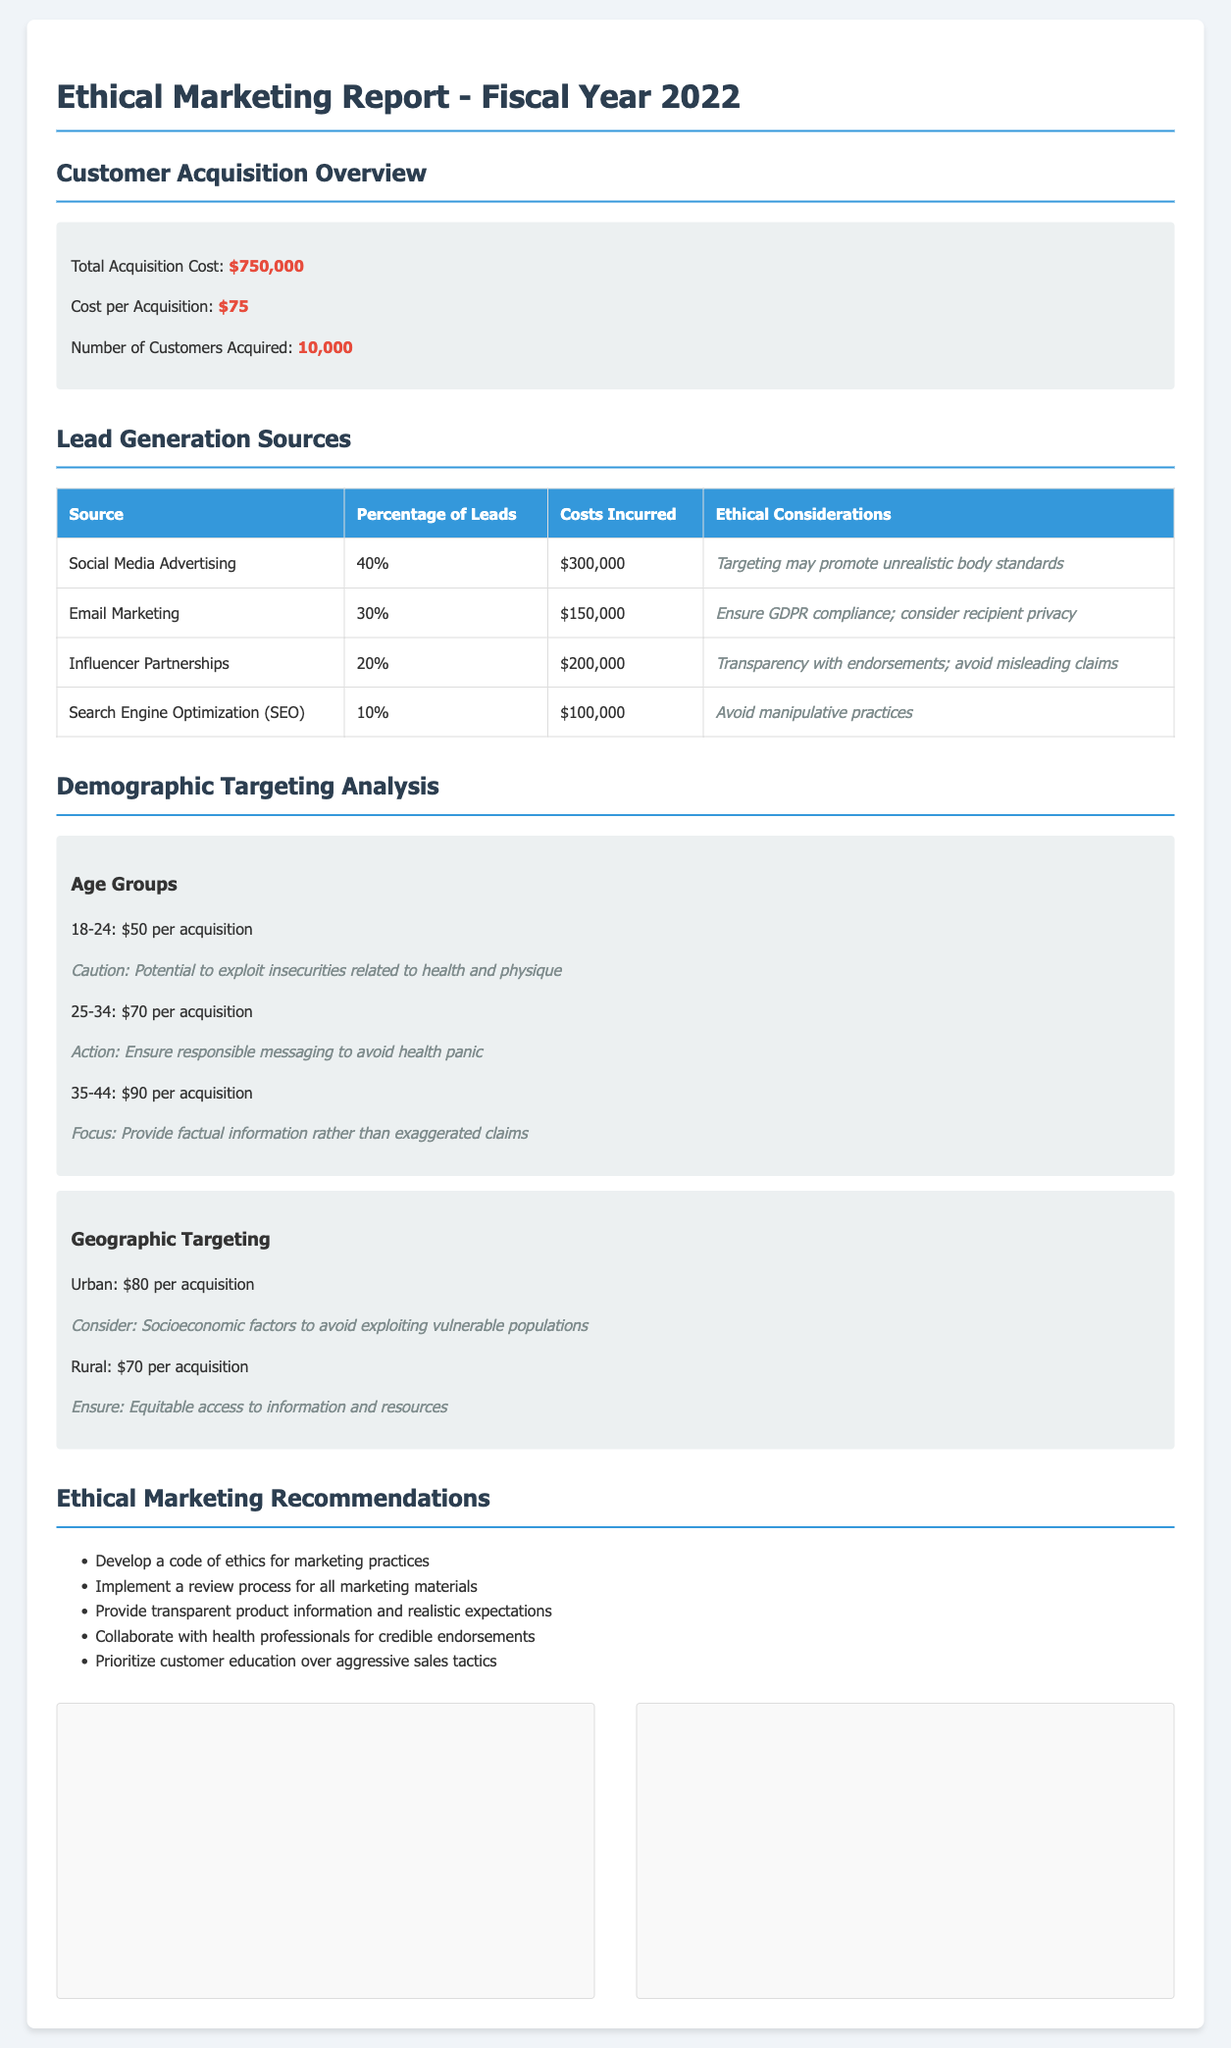what is the total acquisition cost? The total customer acquisition cost is explicitly stated in the document as $750,000.
Answer: $750,000 what is the cost per acquisition? The document specifies that the cost per acquisition is $75.
Answer: $75 how many customers were acquired? The number of customers acquired according to the report is 10,000.
Answer: 10,000 what percentage of leads came from social media advertising? The document indicates that 40% of leads were generated from social media advertising.
Answer: 40% what are the costs incurred for influencer partnerships? The report details that the costs incurred for influencer partnerships amounted to $200,000.
Answer: $200,000 what is the ethical consideration for email marketing? The ethical consideration for email marketing includes ensuring GDPR compliance and considering recipient privacy.
Answer: Ensure GDPR compliance; consider recipient privacy which age group has the highest acquisition cost? The document states that the age group 35-44 has the highest acquisition cost of $90.
Answer: $90 what is the ethical note for targeting urban demographics? The ethical note for targeting urban demographics suggests considering socioeconomic factors to avoid exploiting vulnerable populations.
Answer: Consider: Socioeconomic factors to avoid exploiting vulnerable populations what is the recommended action for the age group 25-34? The recommended action for the age group 25-34 is to ensure responsible messaging to avoid health panic.
Answer: Ensure responsible messaging to avoid health panic what does the report suggest prioritizing over aggressive sales tactics? The report recommends prioritizing customer education over aggressive sales tactics.
Answer: Customer education 